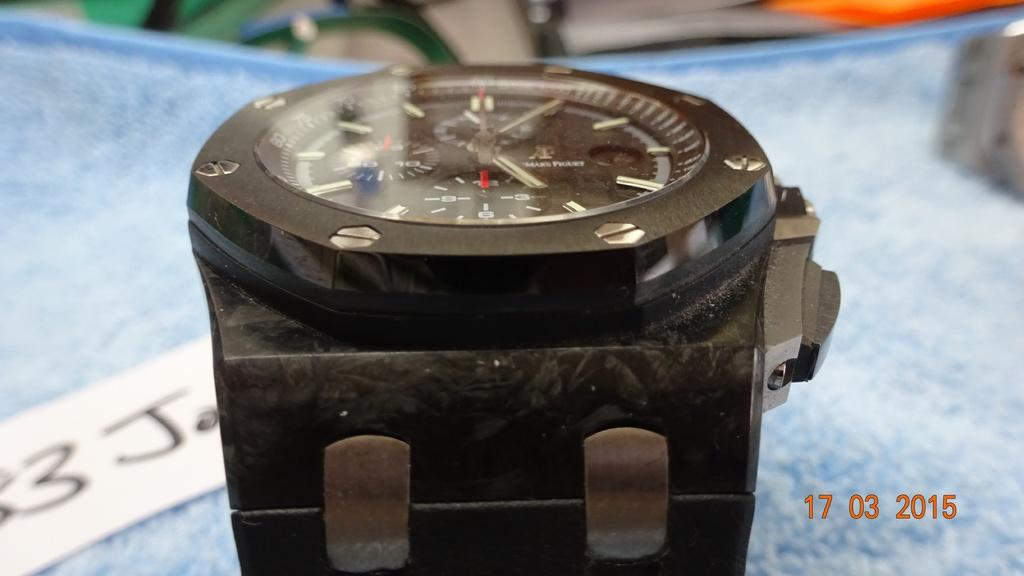<image>
Describe the image concisely. the number 17 indicates the date next to the watch 